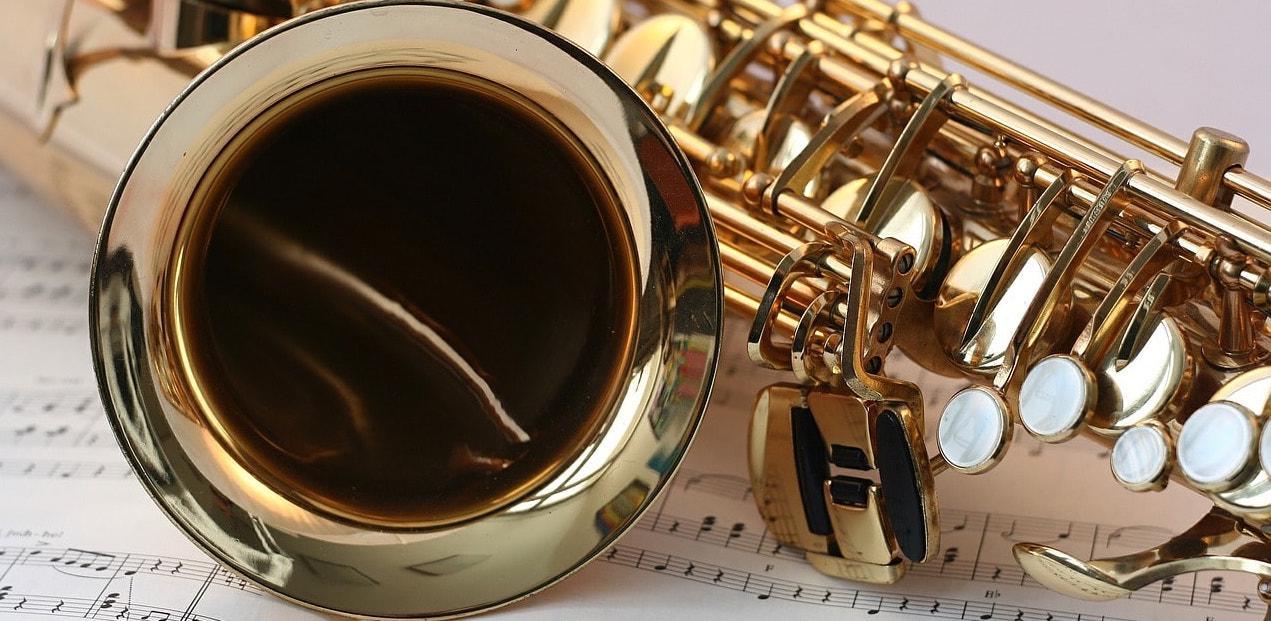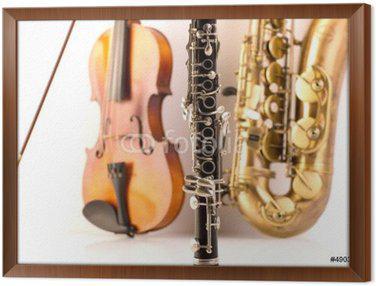The first image is the image on the left, the second image is the image on the right. Given the left and right images, does the statement "Only a single saxophone in each picture." hold true? Answer yes or no. Yes. The first image is the image on the left, the second image is the image on the right. Evaluate the accuracy of this statement regarding the images: "The right image contains a violin, sax and flute.". Is it true? Answer yes or no. Yes. 